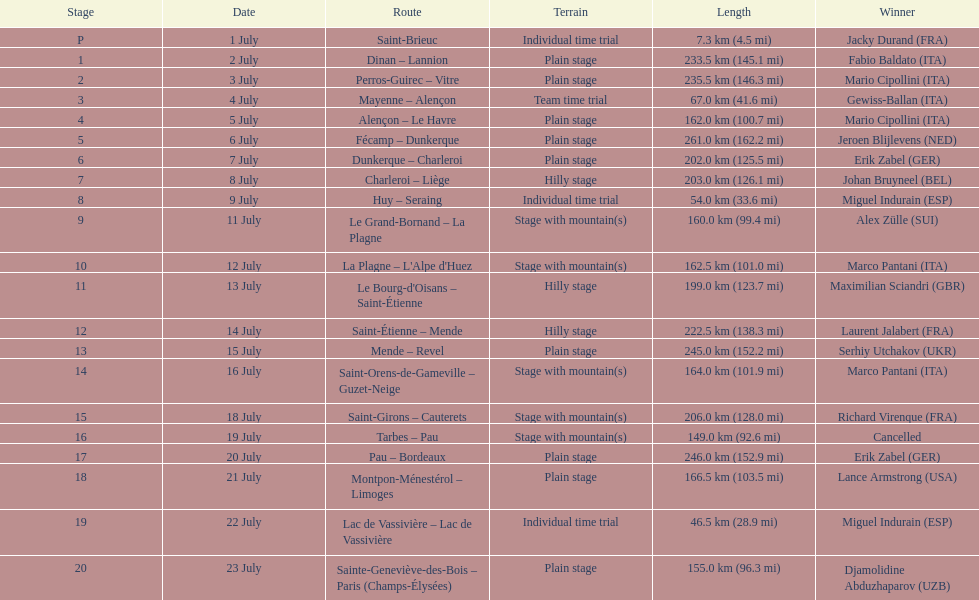How many uninterrupted km were run on july 8th? 203.0 km (126.1 mi). 